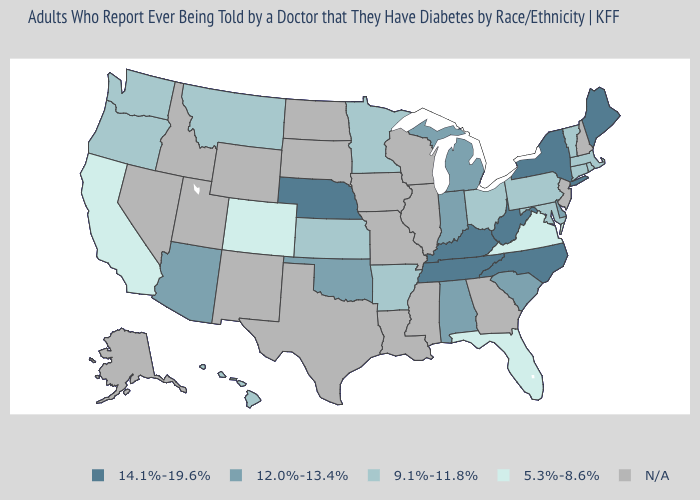What is the highest value in states that border North Dakota?
Give a very brief answer. 9.1%-11.8%. What is the value of Montana?
Write a very short answer. 9.1%-11.8%. What is the value of Georgia?
Short answer required. N/A. What is the highest value in the USA?
Answer briefly. 14.1%-19.6%. What is the value of Vermont?
Answer briefly. 9.1%-11.8%. Among the states that border Massachusetts , which have the highest value?
Short answer required. New York. What is the value of North Carolina?
Concise answer only. 14.1%-19.6%. What is the lowest value in states that border South Carolina?
Keep it brief. 14.1%-19.6%. Among the states that border Utah , which have the highest value?
Quick response, please. Arizona. Is the legend a continuous bar?
Keep it brief. No. Does Arizona have the lowest value in the USA?
Keep it brief. No. Among the states that border Ohio , which have the lowest value?
Short answer required. Pennsylvania. 